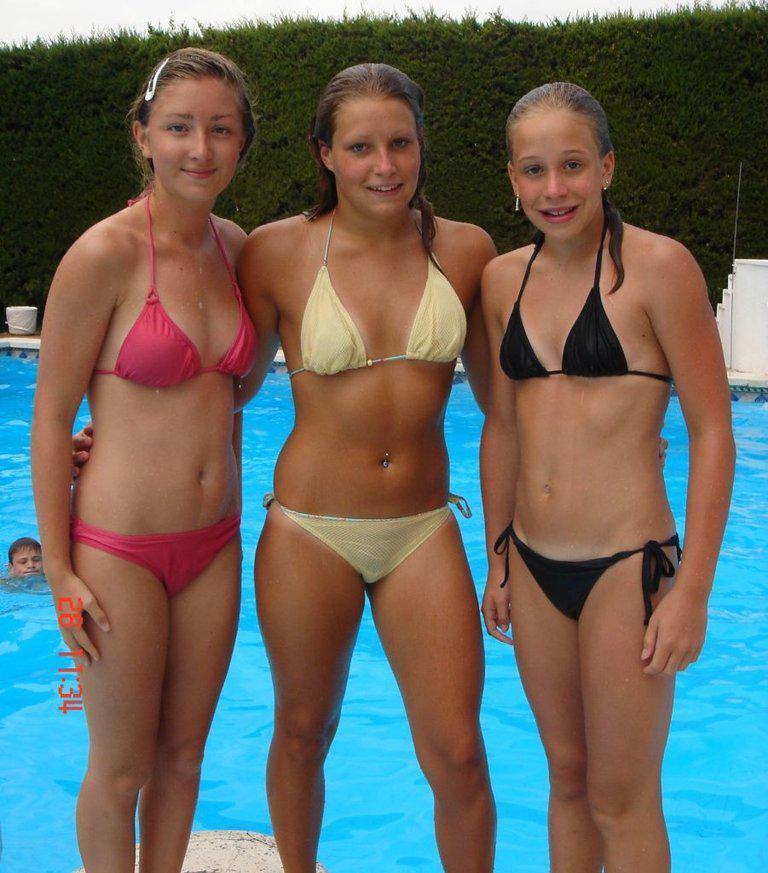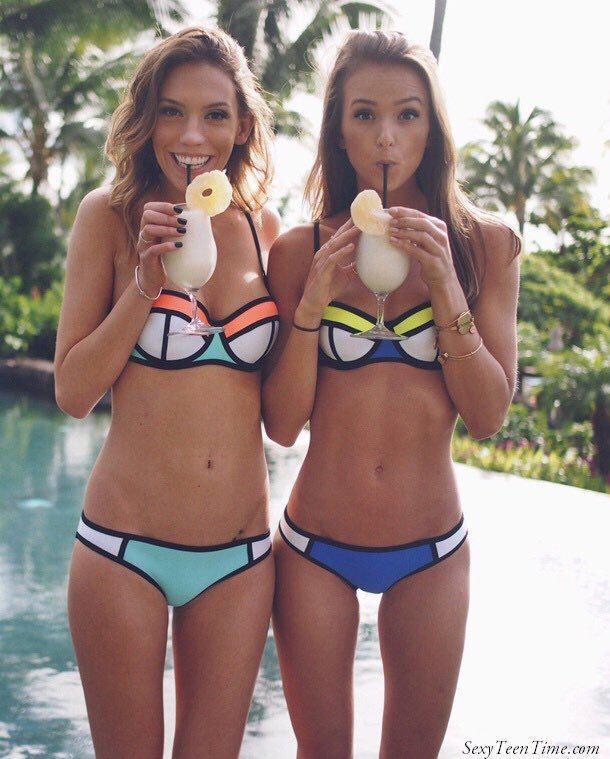The first image is the image on the left, the second image is the image on the right. For the images displayed, is the sentence "One image shows at least three females standing in a line wearing bikinis." factually correct? Answer yes or no. Yes. The first image is the image on the left, the second image is the image on the right. Evaluate the accuracy of this statement regarding the images: "An image shows a camera-facing row of at least three girls, each standing and wearing a different swimsuit color.". Is it true? Answer yes or no. Yes. 